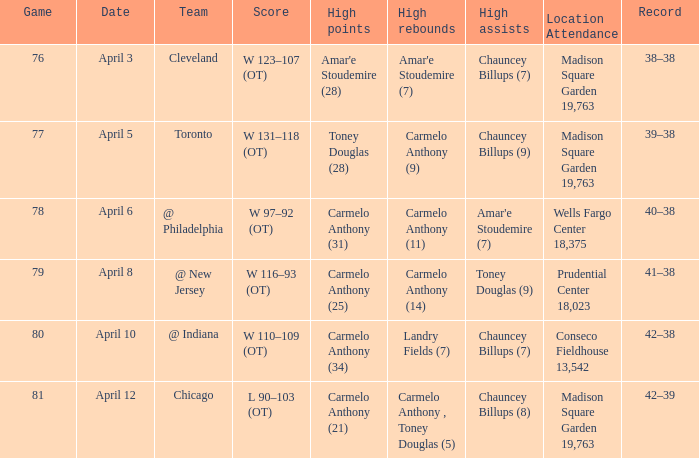Name the location attendance april 5 Madison Square Garden 19,763. 